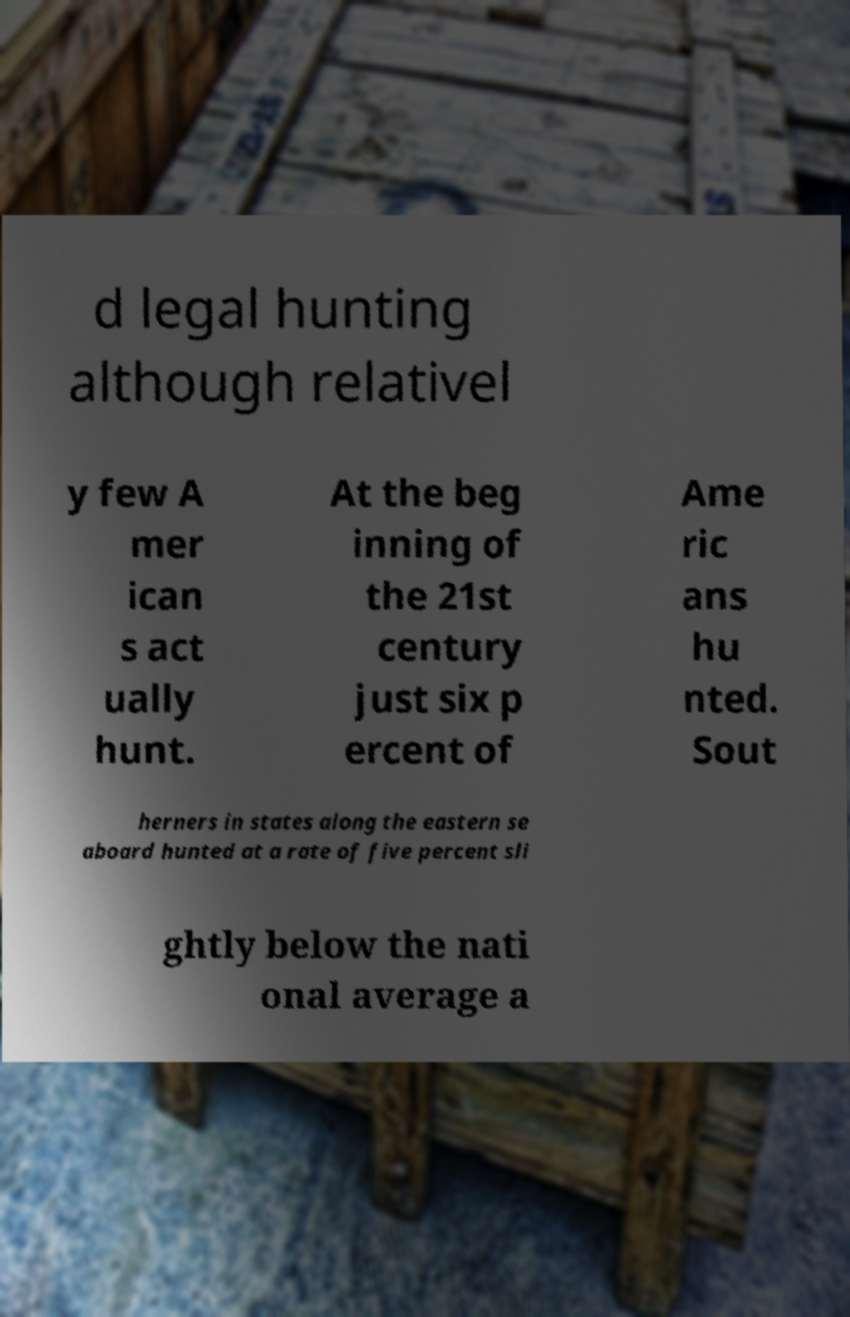Please read and relay the text visible in this image. What does it say? d legal hunting although relativel y few A mer ican s act ually hunt. At the beg inning of the 21st century just six p ercent of Ame ric ans hu nted. Sout herners in states along the eastern se aboard hunted at a rate of five percent sli ghtly below the nati onal average a 